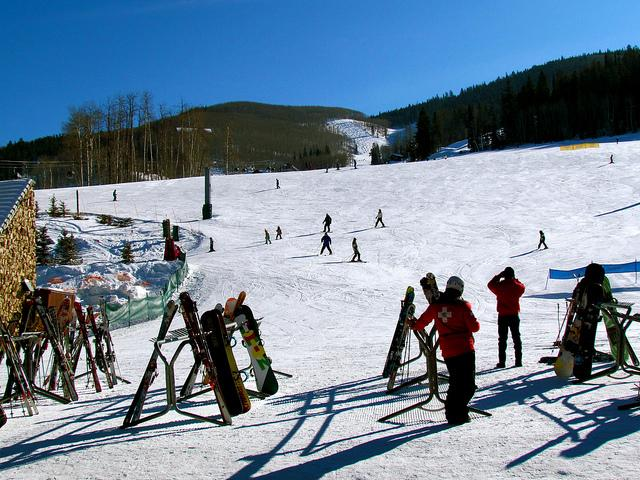The instrument in the picture is used to play for? Please explain your reasoning. skiing. The instrument in the picture is used to ski. 